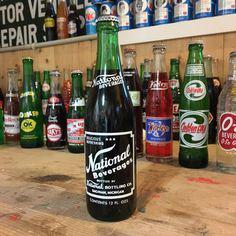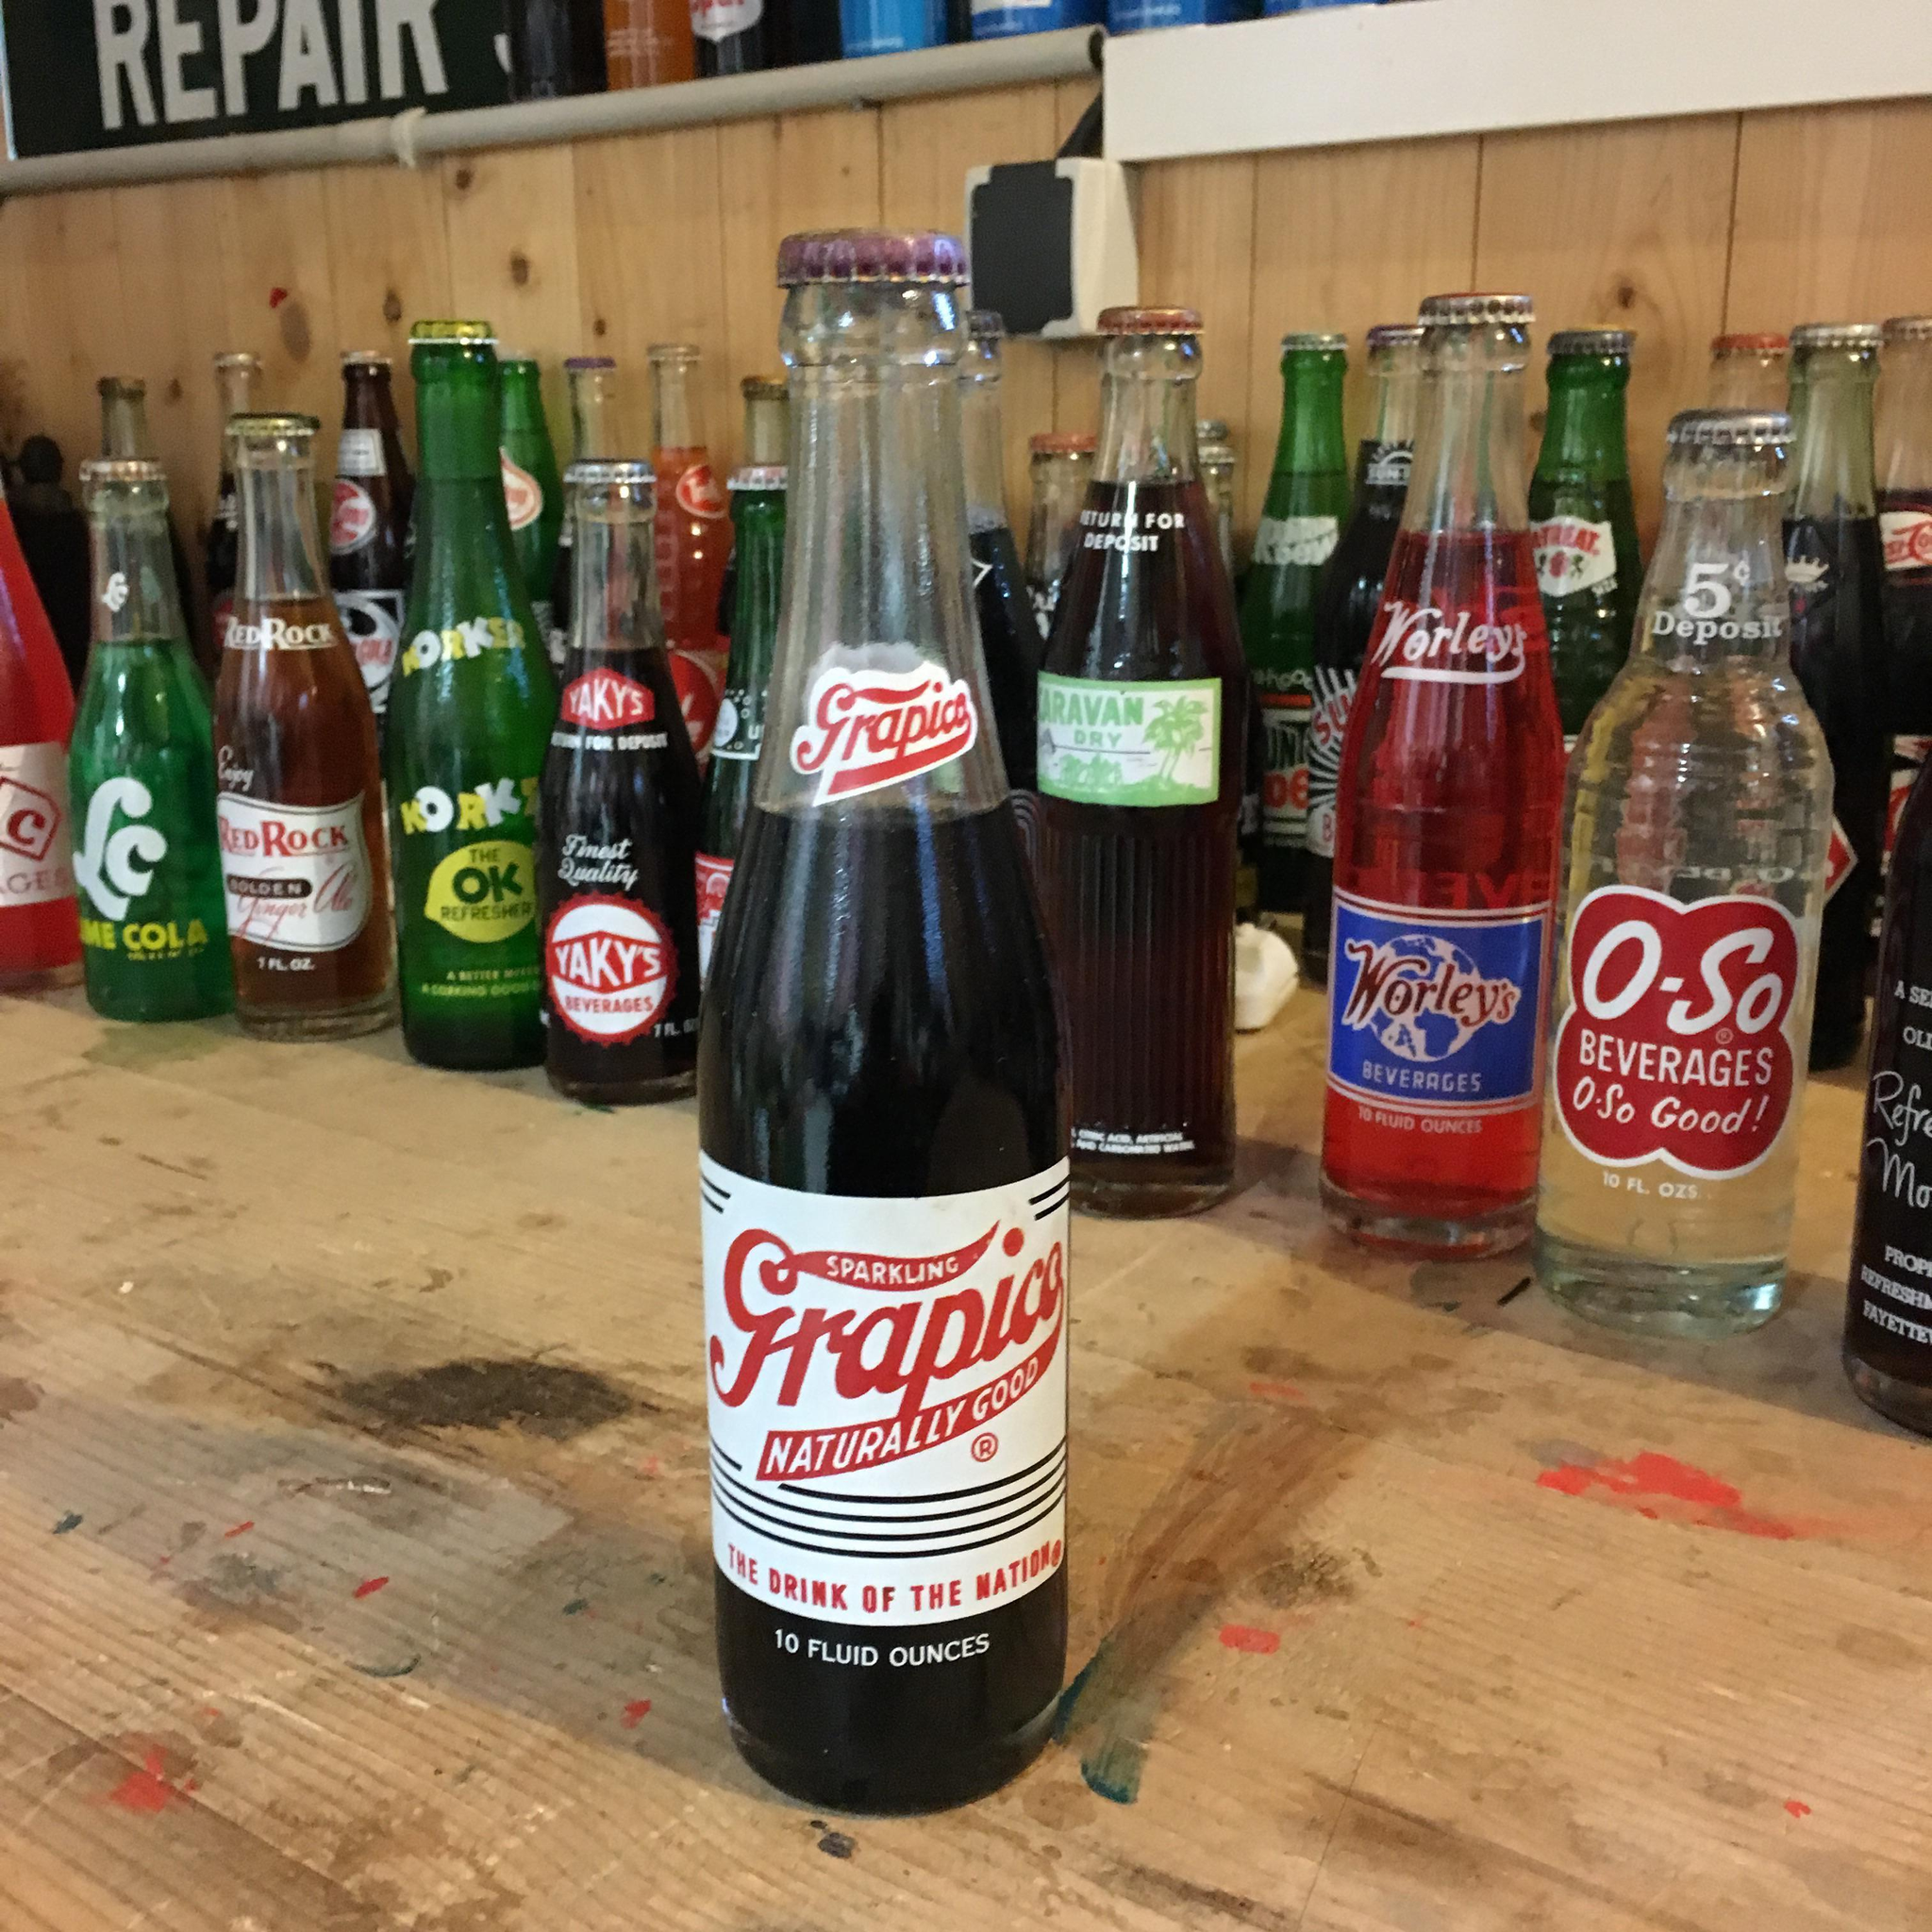The first image is the image on the left, the second image is the image on the right. Given the left and right images, does the statement "The left image features one green bottle of soda standing in front of rows of bottles, and the right image features one clear bottle of brown cola standing in front of rows of bottles." hold true? Answer yes or no. Yes. The first image is the image on the left, the second image is the image on the right. Analyze the images presented: Is the assertion "Each bottle in front of the group is filled with a black liquid." valid? Answer yes or no. Yes. 